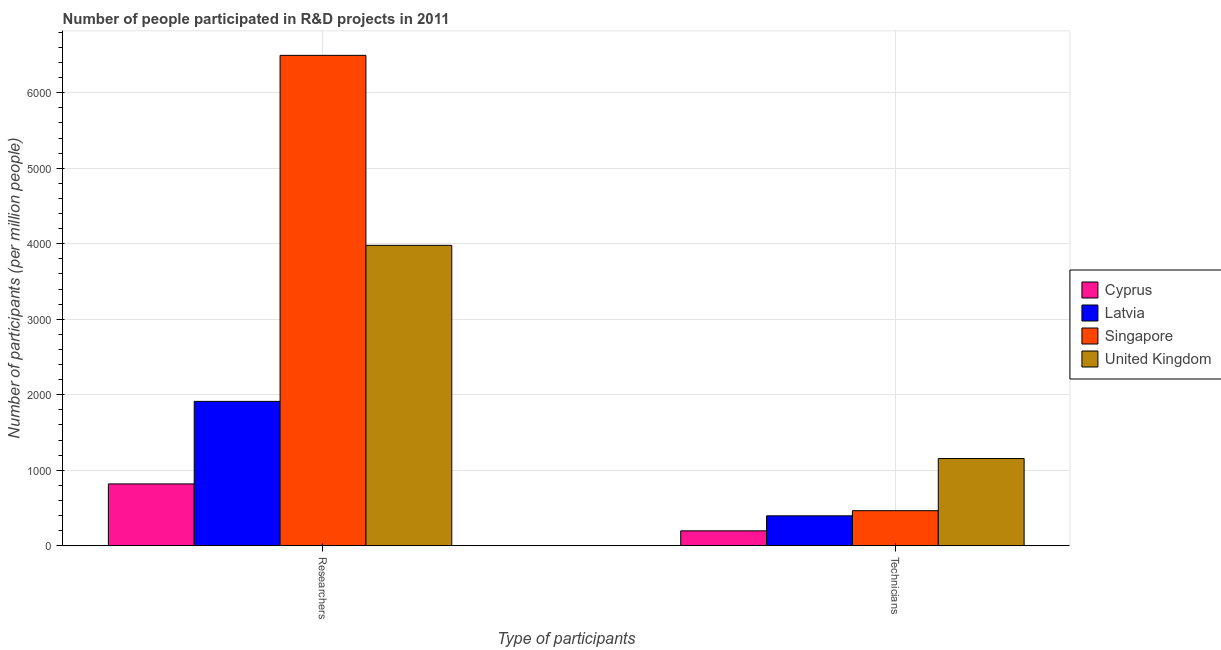How many different coloured bars are there?
Offer a terse response. 4. What is the label of the 1st group of bars from the left?
Offer a very short reply. Researchers. What is the number of technicians in United Kingdom?
Offer a terse response. 1155.52. Across all countries, what is the maximum number of technicians?
Ensure brevity in your answer.  1155.52. Across all countries, what is the minimum number of researchers?
Provide a short and direct response. 819.42. In which country was the number of researchers maximum?
Give a very brief answer. Singapore. In which country was the number of researchers minimum?
Give a very brief answer. Cyprus. What is the total number of technicians in the graph?
Give a very brief answer. 2215.12. What is the difference between the number of researchers in Singapore and that in Latvia?
Offer a terse response. 4583.37. What is the difference between the number of technicians in United Kingdom and the number of researchers in Cyprus?
Keep it short and to the point. 336.1. What is the average number of technicians per country?
Keep it short and to the point. 553.78. What is the difference between the number of technicians and number of researchers in Latvia?
Keep it short and to the point. -1515.75. What is the ratio of the number of researchers in Cyprus to that in United Kingdom?
Keep it short and to the point. 0.21. What does the 1st bar from the left in Researchers represents?
Keep it short and to the point. Cyprus. How many bars are there?
Your response must be concise. 8. Are all the bars in the graph horizontal?
Give a very brief answer. No. What is the difference between two consecutive major ticks on the Y-axis?
Keep it short and to the point. 1000. Are the values on the major ticks of Y-axis written in scientific E-notation?
Your answer should be very brief. No. Does the graph contain any zero values?
Keep it short and to the point. No. Where does the legend appear in the graph?
Your answer should be very brief. Center right. What is the title of the graph?
Provide a succinct answer. Number of people participated in R&D projects in 2011. What is the label or title of the X-axis?
Keep it short and to the point. Type of participants. What is the label or title of the Y-axis?
Your answer should be compact. Number of participants (per million people). What is the Number of participants (per million people) in Cyprus in Researchers?
Your answer should be compact. 819.42. What is the Number of participants (per million people) in Latvia in Researchers?
Ensure brevity in your answer.  1912.62. What is the Number of participants (per million people) of Singapore in Researchers?
Your answer should be compact. 6495.99. What is the Number of participants (per million people) in United Kingdom in Researchers?
Offer a very short reply. 3979.38. What is the Number of participants (per million people) of Cyprus in Technicians?
Your response must be concise. 197.91. What is the Number of participants (per million people) of Latvia in Technicians?
Your answer should be compact. 396.87. What is the Number of participants (per million people) in Singapore in Technicians?
Your answer should be very brief. 464.82. What is the Number of participants (per million people) of United Kingdom in Technicians?
Make the answer very short. 1155.52. Across all Type of participants, what is the maximum Number of participants (per million people) in Cyprus?
Ensure brevity in your answer.  819.42. Across all Type of participants, what is the maximum Number of participants (per million people) in Latvia?
Your response must be concise. 1912.62. Across all Type of participants, what is the maximum Number of participants (per million people) of Singapore?
Provide a succinct answer. 6495.99. Across all Type of participants, what is the maximum Number of participants (per million people) in United Kingdom?
Make the answer very short. 3979.38. Across all Type of participants, what is the minimum Number of participants (per million people) of Cyprus?
Your answer should be compact. 197.91. Across all Type of participants, what is the minimum Number of participants (per million people) in Latvia?
Provide a short and direct response. 396.87. Across all Type of participants, what is the minimum Number of participants (per million people) in Singapore?
Make the answer very short. 464.82. Across all Type of participants, what is the minimum Number of participants (per million people) of United Kingdom?
Your response must be concise. 1155.52. What is the total Number of participants (per million people) of Cyprus in the graph?
Provide a succinct answer. 1017.33. What is the total Number of participants (per million people) in Latvia in the graph?
Provide a succinct answer. 2309.49. What is the total Number of participants (per million people) of Singapore in the graph?
Keep it short and to the point. 6960.8. What is the total Number of participants (per million people) in United Kingdom in the graph?
Offer a very short reply. 5134.91. What is the difference between the Number of participants (per million people) in Cyprus in Researchers and that in Technicians?
Offer a very short reply. 621.51. What is the difference between the Number of participants (per million people) in Latvia in Researchers and that in Technicians?
Keep it short and to the point. 1515.75. What is the difference between the Number of participants (per million people) of Singapore in Researchers and that in Technicians?
Provide a short and direct response. 6031.17. What is the difference between the Number of participants (per million people) of United Kingdom in Researchers and that in Technicians?
Ensure brevity in your answer.  2823.86. What is the difference between the Number of participants (per million people) of Cyprus in Researchers and the Number of participants (per million people) of Latvia in Technicians?
Make the answer very short. 422.55. What is the difference between the Number of participants (per million people) of Cyprus in Researchers and the Number of participants (per million people) of Singapore in Technicians?
Your answer should be compact. 354.6. What is the difference between the Number of participants (per million people) in Cyprus in Researchers and the Number of participants (per million people) in United Kingdom in Technicians?
Your answer should be compact. -336.1. What is the difference between the Number of participants (per million people) in Latvia in Researchers and the Number of participants (per million people) in Singapore in Technicians?
Give a very brief answer. 1447.81. What is the difference between the Number of participants (per million people) of Latvia in Researchers and the Number of participants (per million people) of United Kingdom in Technicians?
Give a very brief answer. 757.1. What is the difference between the Number of participants (per million people) of Singapore in Researchers and the Number of participants (per million people) of United Kingdom in Technicians?
Make the answer very short. 5340.46. What is the average Number of participants (per million people) of Cyprus per Type of participants?
Ensure brevity in your answer.  508.67. What is the average Number of participants (per million people) of Latvia per Type of participants?
Offer a very short reply. 1154.74. What is the average Number of participants (per million people) in Singapore per Type of participants?
Give a very brief answer. 3480.4. What is the average Number of participants (per million people) in United Kingdom per Type of participants?
Provide a succinct answer. 2567.45. What is the difference between the Number of participants (per million people) of Cyprus and Number of participants (per million people) of Latvia in Researchers?
Keep it short and to the point. -1093.2. What is the difference between the Number of participants (per million people) of Cyprus and Number of participants (per million people) of Singapore in Researchers?
Your response must be concise. -5676.57. What is the difference between the Number of participants (per million people) of Cyprus and Number of participants (per million people) of United Kingdom in Researchers?
Offer a very short reply. -3159.96. What is the difference between the Number of participants (per million people) of Latvia and Number of participants (per million people) of Singapore in Researchers?
Ensure brevity in your answer.  -4583.37. What is the difference between the Number of participants (per million people) of Latvia and Number of participants (per million people) of United Kingdom in Researchers?
Your response must be concise. -2066.76. What is the difference between the Number of participants (per million people) in Singapore and Number of participants (per million people) in United Kingdom in Researchers?
Offer a terse response. 2516.6. What is the difference between the Number of participants (per million people) of Cyprus and Number of participants (per million people) of Latvia in Technicians?
Your answer should be very brief. -198.95. What is the difference between the Number of participants (per million people) in Cyprus and Number of participants (per million people) in Singapore in Technicians?
Provide a short and direct response. -266.9. What is the difference between the Number of participants (per million people) in Cyprus and Number of participants (per million people) in United Kingdom in Technicians?
Provide a succinct answer. -957.61. What is the difference between the Number of participants (per million people) of Latvia and Number of participants (per million people) of Singapore in Technicians?
Ensure brevity in your answer.  -67.95. What is the difference between the Number of participants (per million people) in Latvia and Number of participants (per million people) in United Kingdom in Technicians?
Give a very brief answer. -758.66. What is the difference between the Number of participants (per million people) of Singapore and Number of participants (per million people) of United Kingdom in Technicians?
Your answer should be compact. -690.71. What is the ratio of the Number of participants (per million people) of Cyprus in Researchers to that in Technicians?
Keep it short and to the point. 4.14. What is the ratio of the Number of participants (per million people) of Latvia in Researchers to that in Technicians?
Offer a terse response. 4.82. What is the ratio of the Number of participants (per million people) in Singapore in Researchers to that in Technicians?
Give a very brief answer. 13.98. What is the ratio of the Number of participants (per million people) in United Kingdom in Researchers to that in Technicians?
Give a very brief answer. 3.44. What is the difference between the highest and the second highest Number of participants (per million people) in Cyprus?
Make the answer very short. 621.51. What is the difference between the highest and the second highest Number of participants (per million people) of Latvia?
Provide a short and direct response. 1515.75. What is the difference between the highest and the second highest Number of participants (per million people) in Singapore?
Provide a succinct answer. 6031.17. What is the difference between the highest and the second highest Number of participants (per million people) of United Kingdom?
Provide a succinct answer. 2823.86. What is the difference between the highest and the lowest Number of participants (per million people) in Cyprus?
Your response must be concise. 621.51. What is the difference between the highest and the lowest Number of participants (per million people) in Latvia?
Offer a terse response. 1515.75. What is the difference between the highest and the lowest Number of participants (per million people) of Singapore?
Provide a short and direct response. 6031.17. What is the difference between the highest and the lowest Number of participants (per million people) in United Kingdom?
Give a very brief answer. 2823.86. 